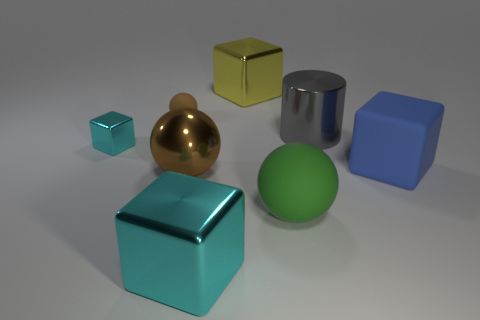The large green matte object has what shape? The large green object in the image appears to have a cube shape, with six equally sized square faces and edges that meet at right angles. 